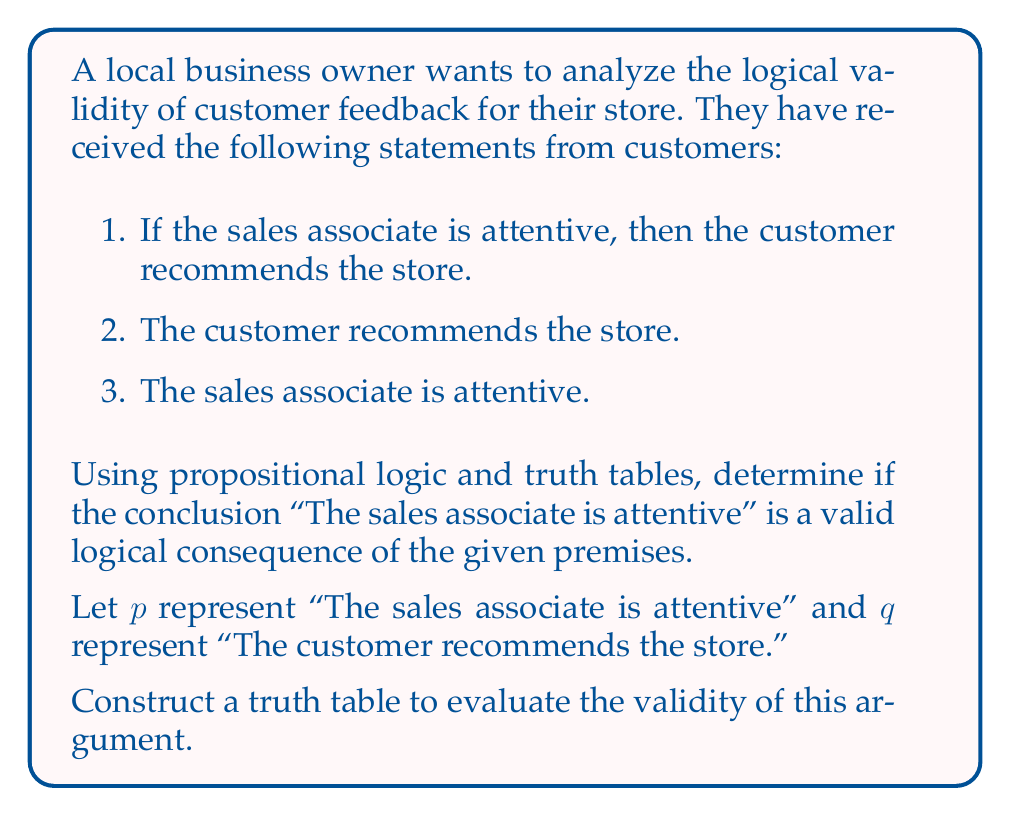Solve this math problem. To determine the logical validity of this argument, we need to construct a truth table and evaluate whether the conclusion necessarily follows from the premises. Let's break it down step by step:

1. First, let's identify the premises and conclusion:
   Premise 1: $p \rightarrow q$ (If the sales associate is attentive, then the customer recommends the store)
   Premise 2: $q$ (The customer recommends the store)
   Conclusion: $p$ (The sales associate is attentive)

2. Construct the truth table:
   We need columns for $p$, $q$, $p \rightarrow q$, and the conjunction of all premises.

   $$
   \begin{array}{|c|c|c|c|c|}
   \hline
   p & q & p \rightarrow q & (p \rightarrow q) \land q & \text{Valid?} \\
   \hline
   T & T & T & T & T \\
   T & F & F & F & T \\
   F & T & T & T & F \\
   F & F & T & F & T \\
   \hline
   \end{array}
   $$

3. Evaluate the premises:
   - The column $p \rightarrow q$ represents Premise 1
   - The column $q$ represents Premise 2
   - The column $(p \rightarrow q) \land q$ represents the conjunction of both premises

4. Check for validity:
   An argument is valid if, in every row where all premises are true, the conclusion is also true. In this case, we need to check if $p$ is true whenever $(p \rightarrow q) \land q$ is true.

   We can see that there are two rows where $(p \rightarrow q) \land q$ is true:
   - When $p$ is true and $q$ is true
   - When $p$ is false and $q$ is true

5. Analyze the results:
   In the first case, the conclusion $p$ is true, which is consistent with validity.
   However, in the second case, the conclusion $p$ is false, while all premises are true.

   This means we have found a counterexample where the premises are true, but the conclusion is false.
Answer: The argument is not logically valid. There exists a scenario (when $p$ is false and $q$ is true) where all premises are true, but the conclusion is false. Therefore, the conclusion "The sales associate is attentive" does not necessarily follow from the given premises. 